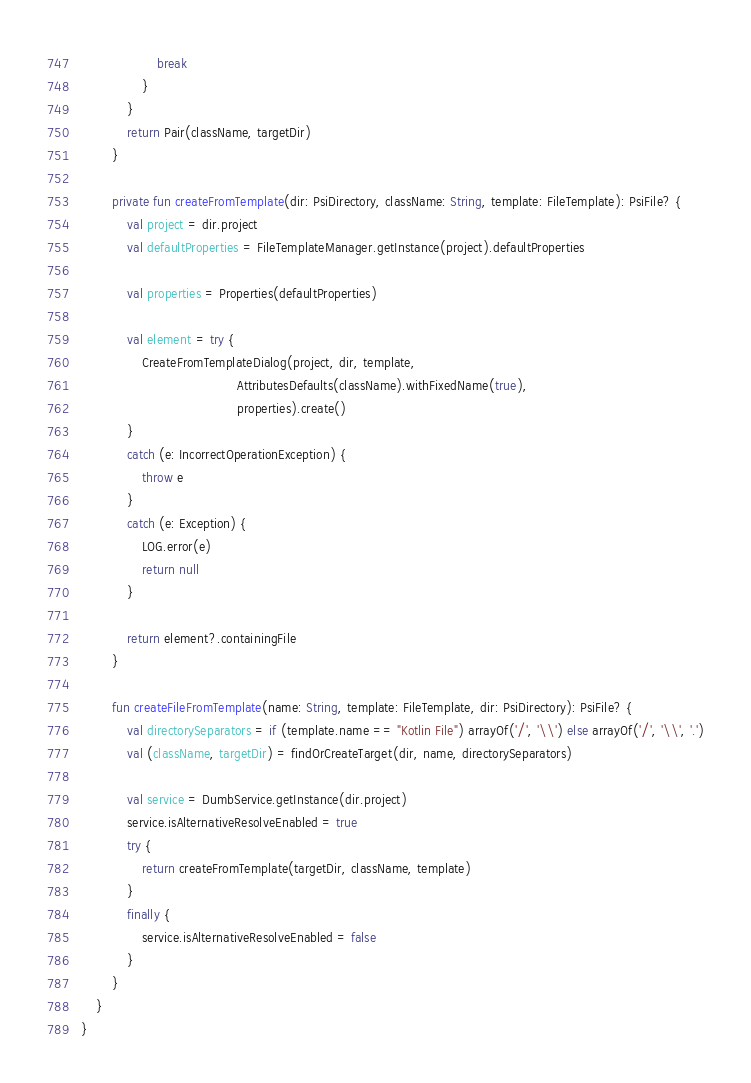Convert code to text. <code><loc_0><loc_0><loc_500><loc_500><_Kotlin_>                    break
                }
            }
            return Pair(className, targetDir)
        }

        private fun createFromTemplate(dir: PsiDirectory, className: String, template: FileTemplate): PsiFile? {
            val project = dir.project
            val defaultProperties = FileTemplateManager.getInstance(project).defaultProperties

            val properties = Properties(defaultProperties)

            val element = try {
                CreateFromTemplateDialog(project, dir, template,
                                         AttributesDefaults(className).withFixedName(true),
                                         properties).create()
            }
            catch (e: IncorrectOperationException) {
                throw e
            }
            catch (e: Exception) {
                LOG.error(e)
                return null
            }

            return element?.containingFile
        }

        fun createFileFromTemplate(name: String, template: FileTemplate, dir: PsiDirectory): PsiFile? {
            val directorySeparators = if (template.name == "Kotlin File") arrayOf('/', '\\') else arrayOf('/', '\\', '.')
            val (className, targetDir) = findOrCreateTarget(dir, name, directorySeparators)

            val service = DumbService.getInstance(dir.project)
            service.isAlternativeResolveEnabled = true
            try {
                return createFromTemplate(targetDir, className, template)
            }
            finally {
                service.isAlternativeResolveEnabled = false
            }
        }
    }
}
</code> 